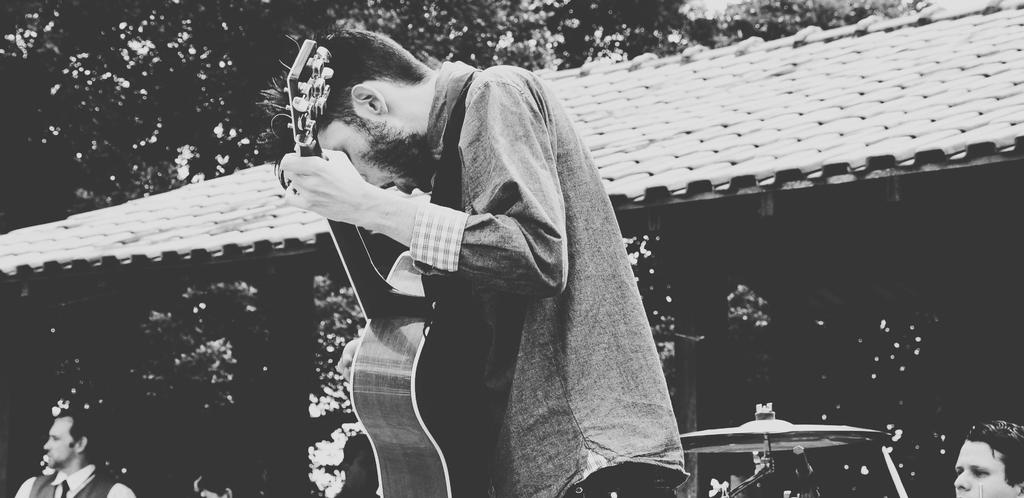What is the man in the image doing? The man is standing in the image and holding a guitar. What object is the man holding in the image? The man is holding a guitar. What can be seen in the background of the image? There is a house and a tree in the background of the image. Where is the drawer located in the image? There is no drawer present in the image. What thought is the man having while holding the guitar in the image? It is impossible to determine the man's thoughts from the image alone. 